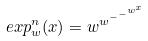Convert formula to latex. <formula><loc_0><loc_0><loc_500><loc_500>e x p _ { w } ^ { n } ( x ) = w ^ { w ^ { - ^ { - ^ { w ^ { x } } } } }</formula> 